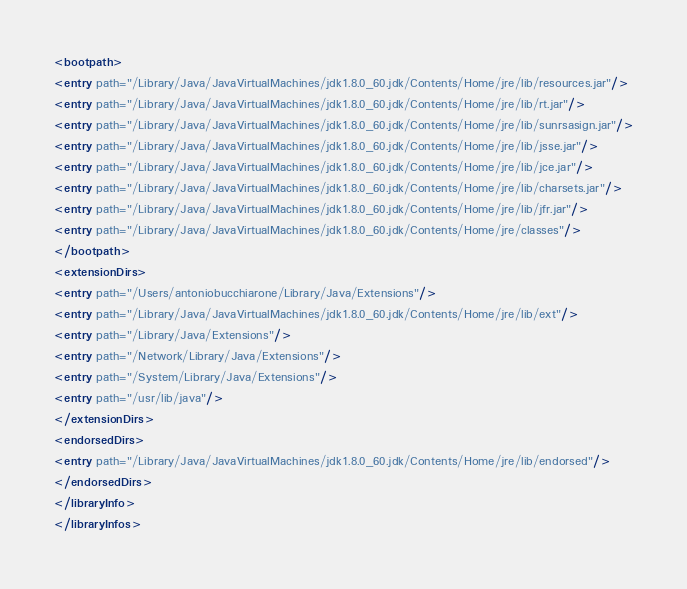<code> <loc_0><loc_0><loc_500><loc_500><_XML_><bootpath>
<entry path="/Library/Java/JavaVirtualMachines/jdk1.8.0_60.jdk/Contents/Home/jre/lib/resources.jar"/>
<entry path="/Library/Java/JavaVirtualMachines/jdk1.8.0_60.jdk/Contents/Home/jre/lib/rt.jar"/>
<entry path="/Library/Java/JavaVirtualMachines/jdk1.8.0_60.jdk/Contents/Home/jre/lib/sunrsasign.jar"/>
<entry path="/Library/Java/JavaVirtualMachines/jdk1.8.0_60.jdk/Contents/Home/jre/lib/jsse.jar"/>
<entry path="/Library/Java/JavaVirtualMachines/jdk1.8.0_60.jdk/Contents/Home/jre/lib/jce.jar"/>
<entry path="/Library/Java/JavaVirtualMachines/jdk1.8.0_60.jdk/Contents/Home/jre/lib/charsets.jar"/>
<entry path="/Library/Java/JavaVirtualMachines/jdk1.8.0_60.jdk/Contents/Home/jre/lib/jfr.jar"/>
<entry path="/Library/Java/JavaVirtualMachines/jdk1.8.0_60.jdk/Contents/Home/jre/classes"/>
</bootpath>
<extensionDirs>
<entry path="/Users/antoniobucchiarone/Library/Java/Extensions"/>
<entry path="/Library/Java/JavaVirtualMachines/jdk1.8.0_60.jdk/Contents/Home/jre/lib/ext"/>
<entry path="/Library/Java/Extensions"/>
<entry path="/Network/Library/Java/Extensions"/>
<entry path="/System/Library/Java/Extensions"/>
<entry path="/usr/lib/java"/>
</extensionDirs>
<endorsedDirs>
<entry path="/Library/Java/JavaVirtualMachines/jdk1.8.0_60.jdk/Contents/Home/jre/lib/endorsed"/>
</endorsedDirs>
</libraryInfo>
</libraryInfos>
</code> 